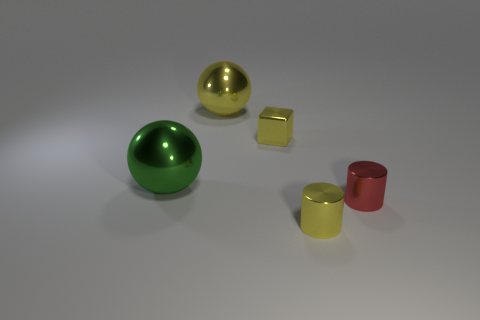Add 4 tiny shiny cylinders. How many objects exist? 9 Subtract all cylinders. How many objects are left? 3 Subtract all green spheres. Subtract all big blue cubes. How many objects are left? 4 Add 1 yellow cubes. How many yellow cubes are left? 2 Add 1 tiny yellow metal cylinders. How many tiny yellow metal cylinders exist? 2 Subtract 0 green cylinders. How many objects are left? 5 